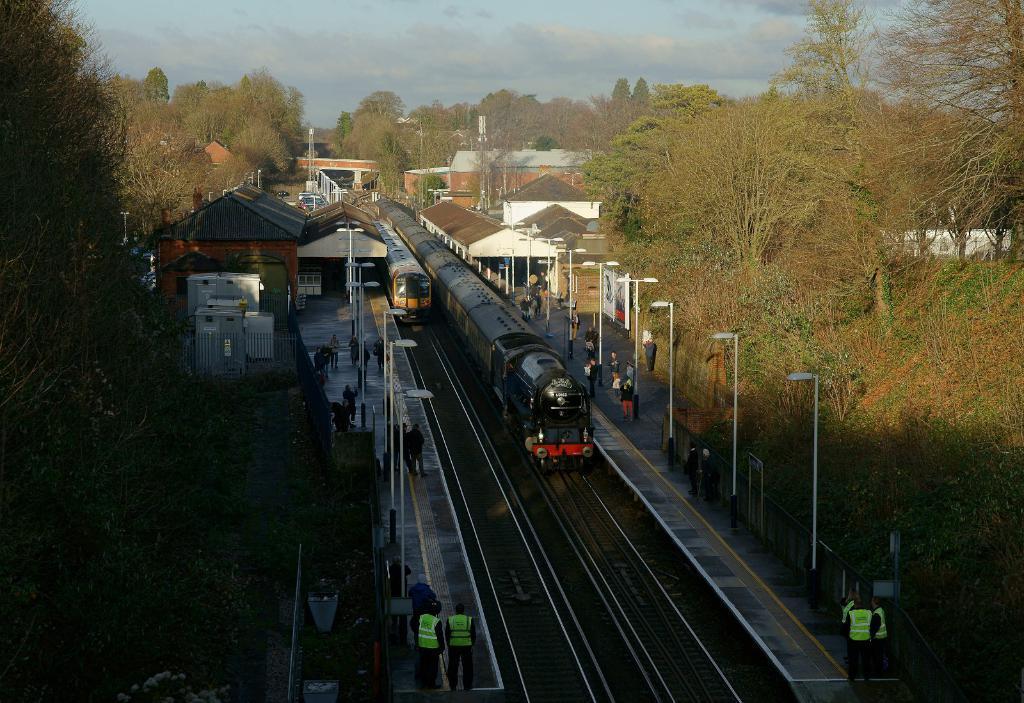Can you describe this image briefly? In the foreground of this picture, there are two trains moving on the track to which on the both sides we can see platform, poles persons standing, trees and the shed. In the background, we can see few buildings, trees, poles, sky and the cloud. 